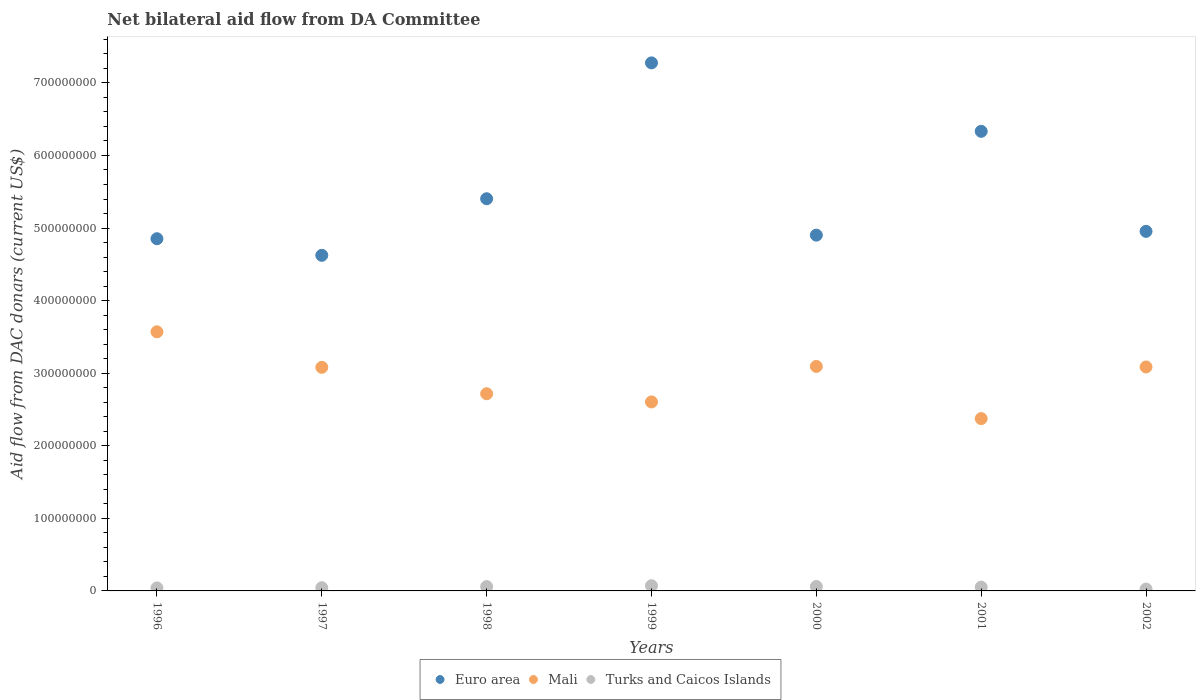How many different coloured dotlines are there?
Offer a very short reply. 3. Is the number of dotlines equal to the number of legend labels?
Keep it short and to the point. Yes. What is the aid flow in in Mali in 2000?
Give a very brief answer. 3.09e+08. Across all years, what is the maximum aid flow in in Mali?
Offer a terse response. 3.57e+08. Across all years, what is the minimum aid flow in in Euro area?
Provide a short and direct response. 4.62e+08. What is the total aid flow in in Mali in the graph?
Offer a terse response. 2.05e+09. What is the difference between the aid flow in in Mali in 1997 and that in 1998?
Provide a succinct answer. 3.64e+07. What is the difference between the aid flow in in Turks and Caicos Islands in 2000 and the aid flow in in Mali in 1996?
Make the answer very short. -3.51e+08. What is the average aid flow in in Euro area per year?
Your answer should be very brief. 5.48e+08. In the year 2002, what is the difference between the aid flow in in Euro area and aid flow in in Turks and Caicos Islands?
Offer a very short reply. 4.93e+08. In how many years, is the aid flow in in Mali greater than 220000000 US$?
Offer a very short reply. 7. What is the ratio of the aid flow in in Turks and Caicos Islands in 1997 to that in 2000?
Provide a succinct answer. 0.73. Is the aid flow in in Mali in 1996 less than that in 1998?
Ensure brevity in your answer.  No. Is the difference between the aid flow in in Euro area in 1997 and 2002 greater than the difference between the aid flow in in Turks and Caicos Islands in 1997 and 2002?
Your answer should be compact. No. What is the difference between the highest and the second highest aid flow in in Euro area?
Provide a succinct answer. 9.43e+07. What is the difference between the highest and the lowest aid flow in in Turks and Caicos Islands?
Your answer should be very brief. 4.60e+06. Is it the case that in every year, the sum of the aid flow in in Mali and aid flow in in Turks and Caicos Islands  is greater than the aid flow in in Euro area?
Your response must be concise. No. Is the aid flow in in Mali strictly greater than the aid flow in in Euro area over the years?
Offer a very short reply. No. How many dotlines are there?
Make the answer very short. 3. How many years are there in the graph?
Offer a terse response. 7. Are the values on the major ticks of Y-axis written in scientific E-notation?
Make the answer very short. No. What is the title of the graph?
Provide a succinct answer. Net bilateral aid flow from DA Committee. Does "Macedonia" appear as one of the legend labels in the graph?
Your response must be concise. No. What is the label or title of the Y-axis?
Your response must be concise. Aid flow from DAC donars (current US$). What is the Aid flow from DAC donars (current US$) in Euro area in 1996?
Your answer should be compact. 4.85e+08. What is the Aid flow from DAC donars (current US$) of Mali in 1996?
Your response must be concise. 3.57e+08. What is the Aid flow from DAC donars (current US$) in Turks and Caicos Islands in 1996?
Your answer should be compact. 4.15e+06. What is the Aid flow from DAC donars (current US$) in Euro area in 1997?
Offer a terse response. 4.62e+08. What is the Aid flow from DAC donars (current US$) of Mali in 1997?
Your response must be concise. 3.08e+08. What is the Aid flow from DAC donars (current US$) of Turks and Caicos Islands in 1997?
Provide a succinct answer. 4.42e+06. What is the Aid flow from DAC donars (current US$) in Euro area in 1998?
Your response must be concise. 5.40e+08. What is the Aid flow from DAC donars (current US$) of Mali in 1998?
Provide a succinct answer. 2.72e+08. What is the Aid flow from DAC donars (current US$) in Turks and Caicos Islands in 1998?
Your response must be concise. 5.97e+06. What is the Aid flow from DAC donars (current US$) of Euro area in 1999?
Give a very brief answer. 7.28e+08. What is the Aid flow from DAC donars (current US$) of Mali in 1999?
Offer a very short reply. 2.60e+08. What is the Aid flow from DAC donars (current US$) in Turks and Caicos Islands in 1999?
Offer a very short reply. 7.21e+06. What is the Aid flow from DAC donars (current US$) in Euro area in 2000?
Provide a short and direct response. 4.90e+08. What is the Aid flow from DAC donars (current US$) of Mali in 2000?
Your response must be concise. 3.09e+08. What is the Aid flow from DAC donars (current US$) in Turks and Caicos Islands in 2000?
Provide a succinct answer. 6.09e+06. What is the Aid flow from DAC donars (current US$) in Euro area in 2001?
Your response must be concise. 6.33e+08. What is the Aid flow from DAC donars (current US$) of Mali in 2001?
Your response must be concise. 2.37e+08. What is the Aid flow from DAC donars (current US$) of Turks and Caicos Islands in 2001?
Your answer should be compact. 5.25e+06. What is the Aid flow from DAC donars (current US$) in Euro area in 2002?
Offer a terse response. 4.95e+08. What is the Aid flow from DAC donars (current US$) in Mali in 2002?
Provide a succinct answer. 3.09e+08. What is the Aid flow from DAC donars (current US$) in Turks and Caicos Islands in 2002?
Your answer should be very brief. 2.61e+06. Across all years, what is the maximum Aid flow from DAC donars (current US$) in Euro area?
Offer a terse response. 7.28e+08. Across all years, what is the maximum Aid flow from DAC donars (current US$) in Mali?
Ensure brevity in your answer.  3.57e+08. Across all years, what is the maximum Aid flow from DAC donars (current US$) of Turks and Caicos Islands?
Offer a terse response. 7.21e+06. Across all years, what is the minimum Aid flow from DAC donars (current US$) of Euro area?
Provide a succinct answer. 4.62e+08. Across all years, what is the minimum Aid flow from DAC donars (current US$) of Mali?
Give a very brief answer. 2.37e+08. Across all years, what is the minimum Aid flow from DAC donars (current US$) of Turks and Caicos Islands?
Your answer should be compact. 2.61e+06. What is the total Aid flow from DAC donars (current US$) of Euro area in the graph?
Your answer should be very brief. 3.83e+09. What is the total Aid flow from DAC donars (current US$) in Mali in the graph?
Ensure brevity in your answer.  2.05e+09. What is the total Aid flow from DAC donars (current US$) of Turks and Caicos Islands in the graph?
Provide a succinct answer. 3.57e+07. What is the difference between the Aid flow from DAC donars (current US$) of Euro area in 1996 and that in 1997?
Your response must be concise. 2.29e+07. What is the difference between the Aid flow from DAC donars (current US$) in Mali in 1996 and that in 1997?
Your answer should be very brief. 4.89e+07. What is the difference between the Aid flow from DAC donars (current US$) in Euro area in 1996 and that in 1998?
Give a very brief answer. -5.51e+07. What is the difference between the Aid flow from DAC donars (current US$) in Mali in 1996 and that in 1998?
Keep it short and to the point. 8.53e+07. What is the difference between the Aid flow from DAC donars (current US$) in Turks and Caicos Islands in 1996 and that in 1998?
Give a very brief answer. -1.82e+06. What is the difference between the Aid flow from DAC donars (current US$) in Euro area in 1996 and that in 1999?
Your answer should be very brief. -2.42e+08. What is the difference between the Aid flow from DAC donars (current US$) in Mali in 1996 and that in 1999?
Offer a very short reply. 9.66e+07. What is the difference between the Aid flow from DAC donars (current US$) in Turks and Caicos Islands in 1996 and that in 1999?
Ensure brevity in your answer.  -3.06e+06. What is the difference between the Aid flow from DAC donars (current US$) of Euro area in 1996 and that in 2000?
Keep it short and to the point. -4.92e+06. What is the difference between the Aid flow from DAC donars (current US$) in Mali in 1996 and that in 2000?
Make the answer very short. 4.77e+07. What is the difference between the Aid flow from DAC donars (current US$) of Turks and Caicos Islands in 1996 and that in 2000?
Give a very brief answer. -1.94e+06. What is the difference between the Aid flow from DAC donars (current US$) of Euro area in 1996 and that in 2001?
Ensure brevity in your answer.  -1.48e+08. What is the difference between the Aid flow from DAC donars (current US$) of Mali in 1996 and that in 2001?
Your answer should be very brief. 1.20e+08. What is the difference between the Aid flow from DAC donars (current US$) of Turks and Caicos Islands in 1996 and that in 2001?
Your answer should be compact. -1.10e+06. What is the difference between the Aid flow from DAC donars (current US$) of Euro area in 1996 and that in 2002?
Provide a short and direct response. -1.01e+07. What is the difference between the Aid flow from DAC donars (current US$) of Mali in 1996 and that in 2002?
Give a very brief answer. 4.84e+07. What is the difference between the Aid flow from DAC donars (current US$) in Turks and Caicos Islands in 1996 and that in 2002?
Your answer should be compact. 1.54e+06. What is the difference between the Aid flow from DAC donars (current US$) in Euro area in 1997 and that in 1998?
Offer a terse response. -7.80e+07. What is the difference between the Aid flow from DAC donars (current US$) of Mali in 1997 and that in 1998?
Give a very brief answer. 3.64e+07. What is the difference between the Aid flow from DAC donars (current US$) of Turks and Caicos Islands in 1997 and that in 1998?
Make the answer very short. -1.55e+06. What is the difference between the Aid flow from DAC donars (current US$) in Euro area in 1997 and that in 1999?
Your answer should be very brief. -2.65e+08. What is the difference between the Aid flow from DAC donars (current US$) in Mali in 1997 and that in 1999?
Make the answer very short. 4.77e+07. What is the difference between the Aid flow from DAC donars (current US$) of Turks and Caicos Islands in 1997 and that in 1999?
Your response must be concise. -2.79e+06. What is the difference between the Aid flow from DAC donars (current US$) of Euro area in 1997 and that in 2000?
Make the answer very short. -2.78e+07. What is the difference between the Aid flow from DAC donars (current US$) of Mali in 1997 and that in 2000?
Offer a very short reply. -1.24e+06. What is the difference between the Aid flow from DAC donars (current US$) in Turks and Caicos Islands in 1997 and that in 2000?
Offer a terse response. -1.67e+06. What is the difference between the Aid flow from DAC donars (current US$) of Euro area in 1997 and that in 2001?
Make the answer very short. -1.71e+08. What is the difference between the Aid flow from DAC donars (current US$) in Mali in 1997 and that in 2001?
Your answer should be compact. 7.06e+07. What is the difference between the Aid flow from DAC donars (current US$) of Turks and Caicos Islands in 1997 and that in 2001?
Give a very brief answer. -8.30e+05. What is the difference between the Aid flow from DAC donars (current US$) of Euro area in 1997 and that in 2002?
Offer a terse response. -3.30e+07. What is the difference between the Aid flow from DAC donars (current US$) of Mali in 1997 and that in 2002?
Your answer should be very brief. -5.00e+05. What is the difference between the Aid flow from DAC donars (current US$) in Turks and Caicos Islands in 1997 and that in 2002?
Give a very brief answer. 1.81e+06. What is the difference between the Aid flow from DAC donars (current US$) in Euro area in 1998 and that in 1999?
Give a very brief answer. -1.87e+08. What is the difference between the Aid flow from DAC donars (current US$) in Mali in 1998 and that in 1999?
Make the answer very short. 1.13e+07. What is the difference between the Aid flow from DAC donars (current US$) of Turks and Caicos Islands in 1998 and that in 1999?
Ensure brevity in your answer.  -1.24e+06. What is the difference between the Aid flow from DAC donars (current US$) in Euro area in 1998 and that in 2000?
Keep it short and to the point. 5.02e+07. What is the difference between the Aid flow from DAC donars (current US$) of Mali in 1998 and that in 2000?
Your response must be concise. -3.76e+07. What is the difference between the Aid flow from DAC donars (current US$) in Euro area in 1998 and that in 2001?
Provide a short and direct response. -9.29e+07. What is the difference between the Aid flow from DAC donars (current US$) of Mali in 1998 and that in 2001?
Keep it short and to the point. 3.43e+07. What is the difference between the Aid flow from DAC donars (current US$) of Turks and Caicos Islands in 1998 and that in 2001?
Your response must be concise. 7.20e+05. What is the difference between the Aid flow from DAC donars (current US$) in Euro area in 1998 and that in 2002?
Your response must be concise. 4.49e+07. What is the difference between the Aid flow from DAC donars (current US$) of Mali in 1998 and that in 2002?
Make the answer very short. -3.69e+07. What is the difference between the Aid flow from DAC donars (current US$) of Turks and Caicos Islands in 1998 and that in 2002?
Give a very brief answer. 3.36e+06. What is the difference between the Aid flow from DAC donars (current US$) of Euro area in 1999 and that in 2000?
Your answer should be compact. 2.37e+08. What is the difference between the Aid flow from DAC donars (current US$) in Mali in 1999 and that in 2000?
Provide a succinct answer. -4.89e+07. What is the difference between the Aid flow from DAC donars (current US$) in Turks and Caicos Islands in 1999 and that in 2000?
Offer a very short reply. 1.12e+06. What is the difference between the Aid flow from DAC donars (current US$) of Euro area in 1999 and that in 2001?
Your answer should be compact. 9.43e+07. What is the difference between the Aid flow from DAC donars (current US$) of Mali in 1999 and that in 2001?
Offer a terse response. 2.30e+07. What is the difference between the Aid flow from DAC donars (current US$) of Turks and Caicos Islands in 1999 and that in 2001?
Your answer should be compact. 1.96e+06. What is the difference between the Aid flow from DAC donars (current US$) of Euro area in 1999 and that in 2002?
Your answer should be very brief. 2.32e+08. What is the difference between the Aid flow from DAC donars (current US$) in Mali in 1999 and that in 2002?
Your response must be concise. -4.82e+07. What is the difference between the Aid flow from DAC donars (current US$) of Turks and Caicos Islands in 1999 and that in 2002?
Ensure brevity in your answer.  4.60e+06. What is the difference between the Aid flow from DAC donars (current US$) of Euro area in 2000 and that in 2001?
Provide a succinct answer. -1.43e+08. What is the difference between the Aid flow from DAC donars (current US$) in Mali in 2000 and that in 2001?
Your answer should be compact. 7.19e+07. What is the difference between the Aid flow from DAC donars (current US$) in Turks and Caicos Islands in 2000 and that in 2001?
Your answer should be compact. 8.40e+05. What is the difference between the Aid flow from DAC donars (current US$) in Euro area in 2000 and that in 2002?
Offer a terse response. -5.22e+06. What is the difference between the Aid flow from DAC donars (current US$) in Mali in 2000 and that in 2002?
Provide a short and direct response. 7.40e+05. What is the difference between the Aid flow from DAC donars (current US$) of Turks and Caicos Islands in 2000 and that in 2002?
Offer a terse response. 3.48e+06. What is the difference between the Aid flow from DAC donars (current US$) in Euro area in 2001 and that in 2002?
Make the answer very short. 1.38e+08. What is the difference between the Aid flow from DAC donars (current US$) in Mali in 2001 and that in 2002?
Offer a terse response. -7.12e+07. What is the difference between the Aid flow from DAC donars (current US$) in Turks and Caicos Islands in 2001 and that in 2002?
Provide a succinct answer. 2.64e+06. What is the difference between the Aid flow from DAC donars (current US$) in Euro area in 1996 and the Aid flow from DAC donars (current US$) in Mali in 1997?
Keep it short and to the point. 1.77e+08. What is the difference between the Aid flow from DAC donars (current US$) in Euro area in 1996 and the Aid flow from DAC donars (current US$) in Turks and Caicos Islands in 1997?
Your response must be concise. 4.81e+08. What is the difference between the Aid flow from DAC donars (current US$) of Mali in 1996 and the Aid flow from DAC donars (current US$) of Turks and Caicos Islands in 1997?
Offer a terse response. 3.53e+08. What is the difference between the Aid flow from DAC donars (current US$) in Euro area in 1996 and the Aid flow from DAC donars (current US$) in Mali in 1998?
Give a very brief answer. 2.14e+08. What is the difference between the Aid flow from DAC donars (current US$) in Euro area in 1996 and the Aid flow from DAC donars (current US$) in Turks and Caicos Islands in 1998?
Offer a terse response. 4.79e+08. What is the difference between the Aid flow from DAC donars (current US$) of Mali in 1996 and the Aid flow from DAC donars (current US$) of Turks and Caicos Islands in 1998?
Provide a succinct answer. 3.51e+08. What is the difference between the Aid flow from DAC donars (current US$) in Euro area in 1996 and the Aid flow from DAC donars (current US$) in Mali in 1999?
Provide a short and direct response. 2.25e+08. What is the difference between the Aid flow from DAC donars (current US$) in Euro area in 1996 and the Aid flow from DAC donars (current US$) in Turks and Caicos Islands in 1999?
Provide a short and direct response. 4.78e+08. What is the difference between the Aid flow from DAC donars (current US$) in Mali in 1996 and the Aid flow from DAC donars (current US$) in Turks and Caicos Islands in 1999?
Give a very brief answer. 3.50e+08. What is the difference between the Aid flow from DAC donars (current US$) in Euro area in 1996 and the Aid flow from DAC donars (current US$) in Mali in 2000?
Provide a succinct answer. 1.76e+08. What is the difference between the Aid flow from DAC donars (current US$) in Euro area in 1996 and the Aid flow from DAC donars (current US$) in Turks and Caicos Islands in 2000?
Offer a terse response. 4.79e+08. What is the difference between the Aid flow from DAC donars (current US$) in Mali in 1996 and the Aid flow from DAC donars (current US$) in Turks and Caicos Islands in 2000?
Your response must be concise. 3.51e+08. What is the difference between the Aid flow from DAC donars (current US$) in Euro area in 1996 and the Aid flow from DAC donars (current US$) in Mali in 2001?
Offer a very short reply. 2.48e+08. What is the difference between the Aid flow from DAC donars (current US$) in Euro area in 1996 and the Aid flow from DAC donars (current US$) in Turks and Caicos Islands in 2001?
Offer a very short reply. 4.80e+08. What is the difference between the Aid flow from DAC donars (current US$) in Mali in 1996 and the Aid flow from DAC donars (current US$) in Turks and Caicos Islands in 2001?
Your response must be concise. 3.52e+08. What is the difference between the Aid flow from DAC donars (current US$) of Euro area in 1996 and the Aid flow from DAC donars (current US$) of Mali in 2002?
Your answer should be very brief. 1.77e+08. What is the difference between the Aid flow from DAC donars (current US$) in Euro area in 1996 and the Aid flow from DAC donars (current US$) in Turks and Caicos Islands in 2002?
Your answer should be compact. 4.83e+08. What is the difference between the Aid flow from DAC donars (current US$) of Mali in 1996 and the Aid flow from DAC donars (current US$) of Turks and Caicos Islands in 2002?
Provide a short and direct response. 3.54e+08. What is the difference between the Aid flow from DAC donars (current US$) in Euro area in 1997 and the Aid flow from DAC donars (current US$) in Mali in 1998?
Give a very brief answer. 1.91e+08. What is the difference between the Aid flow from DAC donars (current US$) of Euro area in 1997 and the Aid flow from DAC donars (current US$) of Turks and Caicos Islands in 1998?
Ensure brevity in your answer.  4.56e+08. What is the difference between the Aid flow from DAC donars (current US$) of Mali in 1997 and the Aid flow from DAC donars (current US$) of Turks and Caicos Islands in 1998?
Your response must be concise. 3.02e+08. What is the difference between the Aid flow from DAC donars (current US$) in Euro area in 1997 and the Aid flow from DAC donars (current US$) in Mali in 1999?
Provide a succinct answer. 2.02e+08. What is the difference between the Aid flow from DAC donars (current US$) in Euro area in 1997 and the Aid flow from DAC donars (current US$) in Turks and Caicos Islands in 1999?
Keep it short and to the point. 4.55e+08. What is the difference between the Aid flow from DAC donars (current US$) of Mali in 1997 and the Aid flow from DAC donars (current US$) of Turks and Caicos Islands in 1999?
Your answer should be very brief. 3.01e+08. What is the difference between the Aid flow from DAC donars (current US$) in Euro area in 1997 and the Aid flow from DAC donars (current US$) in Mali in 2000?
Provide a short and direct response. 1.53e+08. What is the difference between the Aid flow from DAC donars (current US$) of Euro area in 1997 and the Aid flow from DAC donars (current US$) of Turks and Caicos Islands in 2000?
Offer a terse response. 4.56e+08. What is the difference between the Aid flow from DAC donars (current US$) of Mali in 1997 and the Aid flow from DAC donars (current US$) of Turks and Caicos Islands in 2000?
Keep it short and to the point. 3.02e+08. What is the difference between the Aid flow from DAC donars (current US$) in Euro area in 1997 and the Aid flow from DAC donars (current US$) in Mali in 2001?
Offer a terse response. 2.25e+08. What is the difference between the Aid flow from DAC donars (current US$) of Euro area in 1997 and the Aid flow from DAC donars (current US$) of Turks and Caicos Islands in 2001?
Offer a very short reply. 4.57e+08. What is the difference between the Aid flow from DAC donars (current US$) in Mali in 1997 and the Aid flow from DAC donars (current US$) in Turks and Caicos Islands in 2001?
Provide a succinct answer. 3.03e+08. What is the difference between the Aid flow from DAC donars (current US$) in Euro area in 1997 and the Aid flow from DAC donars (current US$) in Mali in 2002?
Provide a short and direct response. 1.54e+08. What is the difference between the Aid flow from DAC donars (current US$) in Euro area in 1997 and the Aid flow from DAC donars (current US$) in Turks and Caicos Islands in 2002?
Your answer should be very brief. 4.60e+08. What is the difference between the Aid flow from DAC donars (current US$) in Mali in 1997 and the Aid flow from DAC donars (current US$) in Turks and Caicos Islands in 2002?
Ensure brevity in your answer.  3.05e+08. What is the difference between the Aid flow from DAC donars (current US$) in Euro area in 1998 and the Aid flow from DAC donars (current US$) in Mali in 1999?
Offer a terse response. 2.80e+08. What is the difference between the Aid flow from DAC donars (current US$) in Euro area in 1998 and the Aid flow from DAC donars (current US$) in Turks and Caicos Islands in 1999?
Give a very brief answer. 5.33e+08. What is the difference between the Aid flow from DAC donars (current US$) in Mali in 1998 and the Aid flow from DAC donars (current US$) in Turks and Caicos Islands in 1999?
Keep it short and to the point. 2.64e+08. What is the difference between the Aid flow from DAC donars (current US$) in Euro area in 1998 and the Aid flow from DAC donars (current US$) in Mali in 2000?
Your response must be concise. 2.31e+08. What is the difference between the Aid flow from DAC donars (current US$) in Euro area in 1998 and the Aid flow from DAC donars (current US$) in Turks and Caicos Islands in 2000?
Offer a terse response. 5.34e+08. What is the difference between the Aid flow from DAC donars (current US$) in Mali in 1998 and the Aid flow from DAC donars (current US$) in Turks and Caicos Islands in 2000?
Your response must be concise. 2.66e+08. What is the difference between the Aid flow from DAC donars (current US$) of Euro area in 1998 and the Aid flow from DAC donars (current US$) of Mali in 2001?
Provide a short and direct response. 3.03e+08. What is the difference between the Aid flow from DAC donars (current US$) in Euro area in 1998 and the Aid flow from DAC donars (current US$) in Turks and Caicos Islands in 2001?
Give a very brief answer. 5.35e+08. What is the difference between the Aid flow from DAC donars (current US$) in Mali in 1998 and the Aid flow from DAC donars (current US$) in Turks and Caicos Islands in 2001?
Offer a terse response. 2.66e+08. What is the difference between the Aid flow from DAC donars (current US$) of Euro area in 1998 and the Aid flow from DAC donars (current US$) of Mali in 2002?
Keep it short and to the point. 2.32e+08. What is the difference between the Aid flow from DAC donars (current US$) in Euro area in 1998 and the Aid flow from DAC donars (current US$) in Turks and Caicos Islands in 2002?
Give a very brief answer. 5.38e+08. What is the difference between the Aid flow from DAC donars (current US$) in Mali in 1998 and the Aid flow from DAC donars (current US$) in Turks and Caicos Islands in 2002?
Your answer should be compact. 2.69e+08. What is the difference between the Aid flow from DAC donars (current US$) in Euro area in 1999 and the Aid flow from DAC donars (current US$) in Mali in 2000?
Give a very brief answer. 4.18e+08. What is the difference between the Aid flow from DAC donars (current US$) in Euro area in 1999 and the Aid flow from DAC donars (current US$) in Turks and Caicos Islands in 2000?
Your answer should be compact. 7.21e+08. What is the difference between the Aid flow from DAC donars (current US$) of Mali in 1999 and the Aid flow from DAC donars (current US$) of Turks and Caicos Islands in 2000?
Make the answer very short. 2.54e+08. What is the difference between the Aid flow from DAC donars (current US$) of Euro area in 1999 and the Aid flow from DAC donars (current US$) of Mali in 2001?
Offer a terse response. 4.90e+08. What is the difference between the Aid flow from DAC donars (current US$) in Euro area in 1999 and the Aid flow from DAC donars (current US$) in Turks and Caicos Islands in 2001?
Keep it short and to the point. 7.22e+08. What is the difference between the Aid flow from DAC donars (current US$) in Mali in 1999 and the Aid flow from DAC donars (current US$) in Turks and Caicos Islands in 2001?
Provide a succinct answer. 2.55e+08. What is the difference between the Aid flow from DAC donars (current US$) in Euro area in 1999 and the Aid flow from DAC donars (current US$) in Mali in 2002?
Offer a terse response. 4.19e+08. What is the difference between the Aid flow from DAC donars (current US$) of Euro area in 1999 and the Aid flow from DAC donars (current US$) of Turks and Caicos Islands in 2002?
Provide a short and direct response. 7.25e+08. What is the difference between the Aid flow from DAC donars (current US$) of Mali in 1999 and the Aid flow from DAC donars (current US$) of Turks and Caicos Islands in 2002?
Provide a succinct answer. 2.58e+08. What is the difference between the Aid flow from DAC donars (current US$) in Euro area in 2000 and the Aid flow from DAC donars (current US$) in Mali in 2001?
Ensure brevity in your answer.  2.53e+08. What is the difference between the Aid flow from DAC donars (current US$) in Euro area in 2000 and the Aid flow from DAC donars (current US$) in Turks and Caicos Islands in 2001?
Your answer should be very brief. 4.85e+08. What is the difference between the Aid flow from DAC donars (current US$) in Mali in 2000 and the Aid flow from DAC donars (current US$) in Turks and Caicos Islands in 2001?
Give a very brief answer. 3.04e+08. What is the difference between the Aid flow from DAC donars (current US$) of Euro area in 2000 and the Aid flow from DAC donars (current US$) of Mali in 2002?
Ensure brevity in your answer.  1.82e+08. What is the difference between the Aid flow from DAC donars (current US$) of Euro area in 2000 and the Aid flow from DAC donars (current US$) of Turks and Caicos Islands in 2002?
Keep it short and to the point. 4.88e+08. What is the difference between the Aid flow from DAC donars (current US$) in Mali in 2000 and the Aid flow from DAC donars (current US$) in Turks and Caicos Islands in 2002?
Offer a very short reply. 3.07e+08. What is the difference between the Aid flow from DAC donars (current US$) of Euro area in 2001 and the Aid flow from DAC donars (current US$) of Mali in 2002?
Your answer should be compact. 3.25e+08. What is the difference between the Aid flow from DAC donars (current US$) of Euro area in 2001 and the Aid flow from DAC donars (current US$) of Turks and Caicos Islands in 2002?
Your response must be concise. 6.31e+08. What is the difference between the Aid flow from DAC donars (current US$) in Mali in 2001 and the Aid flow from DAC donars (current US$) in Turks and Caicos Islands in 2002?
Your answer should be compact. 2.35e+08. What is the average Aid flow from DAC donars (current US$) in Euro area per year?
Keep it short and to the point. 5.48e+08. What is the average Aid flow from DAC donars (current US$) of Mali per year?
Provide a succinct answer. 2.93e+08. What is the average Aid flow from DAC donars (current US$) of Turks and Caicos Islands per year?
Keep it short and to the point. 5.10e+06. In the year 1996, what is the difference between the Aid flow from DAC donars (current US$) of Euro area and Aid flow from DAC donars (current US$) of Mali?
Ensure brevity in your answer.  1.28e+08. In the year 1996, what is the difference between the Aid flow from DAC donars (current US$) of Euro area and Aid flow from DAC donars (current US$) of Turks and Caicos Islands?
Your answer should be compact. 4.81e+08. In the year 1996, what is the difference between the Aid flow from DAC donars (current US$) of Mali and Aid flow from DAC donars (current US$) of Turks and Caicos Islands?
Provide a short and direct response. 3.53e+08. In the year 1997, what is the difference between the Aid flow from DAC donars (current US$) of Euro area and Aid flow from DAC donars (current US$) of Mali?
Provide a succinct answer. 1.54e+08. In the year 1997, what is the difference between the Aid flow from DAC donars (current US$) of Euro area and Aid flow from DAC donars (current US$) of Turks and Caicos Islands?
Offer a very short reply. 4.58e+08. In the year 1997, what is the difference between the Aid flow from DAC donars (current US$) of Mali and Aid flow from DAC donars (current US$) of Turks and Caicos Islands?
Your answer should be compact. 3.04e+08. In the year 1998, what is the difference between the Aid flow from DAC donars (current US$) of Euro area and Aid flow from DAC donars (current US$) of Mali?
Your response must be concise. 2.69e+08. In the year 1998, what is the difference between the Aid flow from DAC donars (current US$) in Euro area and Aid flow from DAC donars (current US$) in Turks and Caicos Islands?
Your response must be concise. 5.34e+08. In the year 1998, what is the difference between the Aid flow from DAC donars (current US$) in Mali and Aid flow from DAC donars (current US$) in Turks and Caicos Islands?
Your answer should be very brief. 2.66e+08. In the year 1999, what is the difference between the Aid flow from DAC donars (current US$) of Euro area and Aid flow from DAC donars (current US$) of Mali?
Offer a very short reply. 4.67e+08. In the year 1999, what is the difference between the Aid flow from DAC donars (current US$) of Euro area and Aid flow from DAC donars (current US$) of Turks and Caicos Islands?
Your response must be concise. 7.20e+08. In the year 1999, what is the difference between the Aid flow from DAC donars (current US$) in Mali and Aid flow from DAC donars (current US$) in Turks and Caicos Islands?
Provide a succinct answer. 2.53e+08. In the year 2000, what is the difference between the Aid flow from DAC donars (current US$) of Euro area and Aid flow from DAC donars (current US$) of Mali?
Your answer should be compact. 1.81e+08. In the year 2000, what is the difference between the Aid flow from DAC donars (current US$) in Euro area and Aid flow from DAC donars (current US$) in Turks and Caicos Islands?
Provide a short and direct response. 4.84e+08. In the year 2000, what is the difference between the Aid flow from DAC donars (current US$) in Mali and Aid flow from DAC donars (current US$) in Turks and Caicos Islands?
Your response must be concise. 3.03e+08. In the year 2001, what is the difference between the Aid flow from DAC donars (current US$) of Euro area and Aid flow from DAC donars (current US$) of Mali?
Offer a terse response. 3.96e+08. In the year 2001, what is the difference between the Aid flow from DAC donars (current US$) in Euro area and Aid flow from DAC donars (current US$) in Turks and Caicos Islands?
Your answer should be very brief. 6.28e+08. In the year 2001, what is the difference between the Aid flow from DAC donars (current US$) in Mali and Aid flow from DAC donars (current US$) in Turks and Caicos Islands?
Provide a short and direct response. 2.32e+08. In the year 2002, what is the difference between the Aid flow from DAC donars (current US$) of Euro area and Aid flow from DAC donars (current US$) of Mali?
Provide a succinct answer. 1.87e+08. In the year 2002, what is the difference between the Aid flow from DAC donars (current US$) in Euro area and Aid flow from DAC donars (current US$) in Turks and Caicos Islands?
Ensure brevity in your answer.  4.93e+08. In the year 2002, what is the difference between the Aid flow from DAC donars (current US$) of Mali and Aid flow from DAC donars (current US$) of Turks and Caicos Islands?
Make the answer very short. 3.06e+08. What is the ratio of the Aid flow from DAC donars (current US$) in Euro area in 1996 to that in 1997?
Provide a succinct answer. 1.05. What is the ratio of the Aid flow from DAC donars (current US$) in Mali in 1996 to that in 1997?
Provide a succinct answer. 1.16. What is the ratio of the Aid flow from DAC donars (current US$) of Turks and Caicos Islands in 1996 to that in 1997?
Keep it short and to the point. 0.94. What is the ratio of the Aid flow from DAC donars (current US$) of Euro area in 1996 to that in 1998?
Make the answer very short. 0.9. What is the ratio of the Aid flow from DAC donars (current US$) in Mali in 1996 to that in 1998?
Ensure brevity in your answer.  1.31. What is the ratio of the Aid flow from DAC donars (current US$) of Turks and Caicos Islands in 1996 to that in 1998?
Ensure brevity in your answer.  0.7. What is the ratio of the Aid flow from DAC donars (current US$) in Euro area in 1996 to that in 1999?
Make the answer very short. 0.67. What is the ratio of the Aid flow from DAC donars (current US$) of Mali in 1996 to that in 1999?
Your response must be concise. 1.37. What is the ratio of the Aid flow from DAC donars (current US$) of Turks and Caicos Islands in 1996 to that in 1999?
Provide a short and direct response. 0.58. What is the ratio of the Aid flow from DAC donars (current US$) of Euro area in 1996 to that in 2000?
Keep it short and to the point. 0.99. What is the ratio of the Aid flow from DAC donars (current US$) in Mali in 1996 to that in 2000?
Offer a very short reply. 1.15. What is the ratio of the Aid flow from DAC donars (current US$) of Turks and Caicos Islands in 1996 to that in 2000?
Your answer should be compact. 0.68. What is the ratio of the Aid flow from DAC donars (current US$) of Euro area in 1996 to that in 2001?
Offer a very short reply. 0.77. What is the ratio of the Aid flow from DAC donars (current US$) in Mali in 1996 to that in 2001?
Provide a short and direct response. 1.5. What is the ratio of the Aid flow from DAC donars (current US$) of Turks and Caicos Islands in 1996 to that in 2001?
Give a very brief answer. 0.79. What is the ratio of the Aid flow from DAC donars (current US$) of Euro area in 1996 to that in 2002?
Keep it short and to the point. 0.98. What is the ratio of the Aid flow from DAC donars (current US$) of Mali in 1996 to that in 2002?
Your response must be concise. 1.16. What is the ratio of the Aid flow from DAC donars (current US$) of Turks and Caicos Islands in 1996 to that in 2002?
Offer a very short reply. 1.59. What is the ratio of the Aid flow from DAC donars (current US$) in Euro area in 1997 to that in 1998?
Your response must be concise. 0.86. What is the ratio of the Aid flow from DAC donars (current US$) in Mali in 1997 to that in 1998?
Your response must be concise. 1.13. What is the ratio of the Aid flow from DAC donars (current US$) of Turks and Caicos Islands in 1997 to that in 1998?
Provide a short and direct response. 0.74. What is the ratio of the Aid flow from DAC donars (current US$) of Euro area in 1997 to that in 1999?
Your answer should be compact. 0.64. What is the ratio of the Aid flow from DAC donars (current US$) in Mali in 1997 to that in 1999?
Offer a terse response. 1.18. What is the ratio of the Aid flow from DAC donars (current US$) of Turks and Caicos Islands in 1997 to that in 1999?
Provide a short and direct response. 0.61. What is the ratio of the Aid flow from DAC donars (current US$) in Euro area in 1997 to that in 2000?
Offer a very short reply. 0.94. What is the ratio of the Aid flow from DAC donars (current US$) of Turks and Caicos Islands in 1997 to that in 2000?
Offer a terse response. 0.73. What is the ratio of the Aid flow from DAC donars (current US$) in Euro area in 1997 to that in 2001?
Give a very brief answer. 0.73. What is the ratio of the Aid flow from DAC donars (current US$) of Mali in 1997 to that in 2001?
Your response must be concise. 1.3. What is the ratio of the Aid flow from DAC donars (current US$) of Turks and Caicos Islands in 1997 to that in 2001?
Offer a terse response. 0.84. What is the ratio of the Aid flow from DAC donars (current US$) of Euro area in 1997 to that in 2002?
Your answer should be very brief. 0.93. What is the ratio of the Aid flow from DAC donars (current US$) in Turks and Caicos Islands in 1997 to that in 2002?
Provide a succinct answer. 1.69. What is the ratio of the Aid flow from DAC donars (current US$) of Euro area in 1998 to that in 1999?
Provide a succinct answer. 0.74. What is the ratio of the Aid flow from DAC donars (current US$) in Mali in 1998 to that in 1999?
Your response must be concise. 1.04. What is the ratio of the Aid flow from DAC donars (current US$) of Turks and Caicos Islands in 1998 to that in 1999?
Make the answer very short. 0.83. What is the ratio of the Aid flow from DAC donars (current US$) of Euro area in 1998 to that in 2000?
Give a very brief answer. 1.1. What is the ratio of the Aid flow from DAC donars (current US$) of Mali in 1998 to that in 2000?
Your answer should be compact. 0.88. What is the ratio of the Aid flow from DAC donars (current US$) of Turks and Caicos Islands in 1998 to that in 2000?
Ensure brevity in your answer.  0.98. What is the ratio of the Aid flow from DAC donars (current US$) of Euro area in 1998 to that in 2001?
Offer a terse response. 0.85. What is the ratio of the Aid flow from DAC donars (current US$) of Mali in 1998 to that in 2001?
Your answer should be compact. 1.14. What is the ratio of the Aid flow from DAC donars (current US$) in Turks and Caicos Islands in 1998 to that in 2001?
Provide a short and direct response. 1.14. What is the ratio of the Aid flow from DAC donars (current US$) in Euro area in 1998 to that in 2002?
Your response must be concise. 1.09. What is the ratio of the Aid flow from DAC donars (current US$) in Mali in 1998 to that in 2002?
Provide a short and direct response. 0.88. What is the ratio of the Aid flow from DAC donars (current US$) in Turks and Caicos Islands in 1998 to that in 2002?
Provide a succinct answer. 2.29. What is the ratio of the Aid flow from DAC donars (current US$) of Euro area in 1999 to that in 2000?
Your response must be concise. 1.48. What is the ratio of the Aid flow from DAC donars (current US$) in Mali in 1999 to that in 2000?
Provide a short and direct response. 0.84. What is the ratio of the Aid flow from DAC donars (current US$) in Turks and Caicos Islands in 1999 to that in 2000?
Provide a succinct answer. 1.18. What is the ratio of the Aid flow from DAC donars (current US$) in Euro area in 1999 to that in 2001?
Offer a very short reply. 1.15. What is the ratio of the Aid flow from DAC donars (current US$) in Mali in 1999 to that in 2001?
Your response must be concise. 1.1. What is the ratio of the Aid flow from DAC donars (current US$) of Turks and Caicos Islands in 1999 to that in 2001?
Ensure brevity in your answer.  1.37. What is the ratio of the Aid flow from DAC donars (current US$) of Euro area in 1999 to that in 2002?
Provide a short and direct response. 1.47. What is the ratio of the Aid flow from DAC donars (current US$) in Mali in 1999 to that in 2002?
Provide a short and direct response. 0.84. What is the ratio of the Aid flow from DAC donars (current US$) in Turks and Caicos Islands in 1999 to that in 2002?
Give a very brief answer. 2.76. What is the ratio of the Aid flow from DAC donars (current US$) of Euro area in 2000 to that in 2001?
Your answer should be compact. 0.77. What is the ratio of the Aid flow from DAC donars (current US$) in Mali in 2000 to that in 2001?
Give a very brief answer. 1.3. What is the ratio of the Aid flow from DAC donars (current US$) of Turks and Caicos Islands in 2000 to that in 2001?
Provide a succinct answer. 1.16. What is the ratio of the Aid flow from DAC donars (current US$) in Euro area in 2000 to that in 2002?
Offer a very short reply. 0.99. What is the ratio of the Aid flow from DAC donars (current US$) in Turks and Caicos Islands in 2000 to that in 2002?
Provide a succinct answer. 2.33. What is the ratio of the Aid flow from DAC donars (current US$) of Euro area in 2001 to that in 2002?
Provide a succinct answer. 1.28. What is the ratio of the Aid flow from DAC donars (current US$) in Mali in 2001 to that in 2002?
Keep it short and to the point. 0.77. What is the ratio of the Aid flow from DAC donars (current US$) in Turks and Caicos Islands in 2001 to that in 2002?
Offer a terse response. 2.01. What is the difference between the highest and the second highest Aid flow from DAC donars (current US$) in Euro area?
Provide a succinct answer. 9.43e+07. What is the difference between the highest and the second highest Aid flow from DAC donars (current US$) in Mali?
Keep it short and to the point. 4.77e+07. What is the difference between the highest and the second highest Aid flow from DAC donars (current US$) of Turks and Caicos Islands?
Provide a short and direct response. 1.12e+06. What is the difference between the highest and the lowest Aid flow from DAC donars (current US$) of Euro area?
Provide a short and direct response. 2.65e+08. What is the difference between the highest and the lowest Aid flow from DAC donars (current US$) in Mali?
Offer a very short reply. 1.20e+08. What is the difference between the highest and the lowest Aid flow from DAC donars (current US$) of Turks and Caicos Islands?
Give a very brief answer. 4.60e+06. 